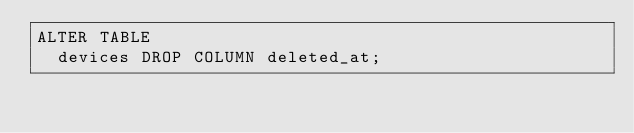<code> <loc_0><loc_0><loc_500><loc_500><_SQL_>ALTER TABLE
  devices DROP COLUMN deleted_at;
</code> 